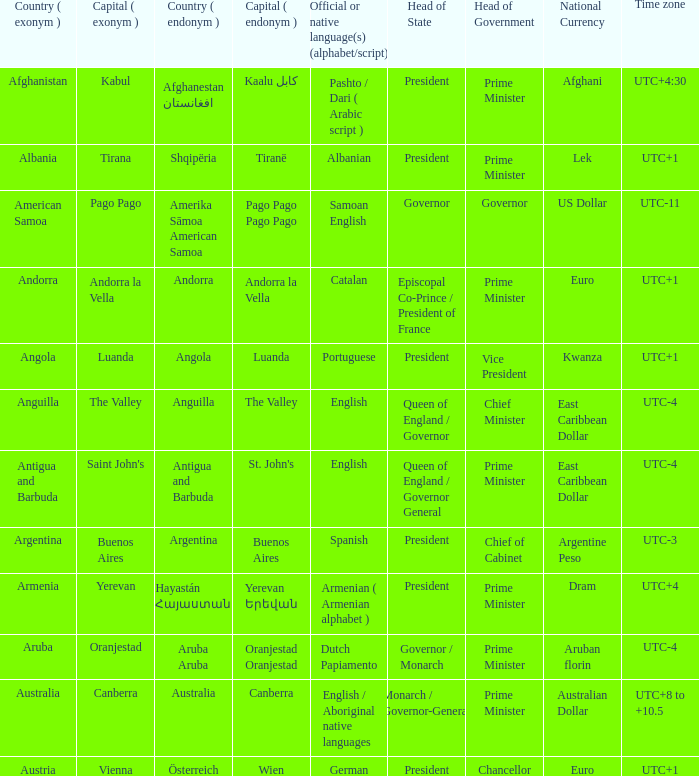What is the local name given to the city of Canberra? Canberra. Would you mind parsing the complete table? {'header': ['Country ( exonym )', 'Capital ( exonym )', 'Country ( endonym )', 'Capital ( endonym )', 'Official or native language(s) (alphabet/script)', 'Head of State', 'Head of Government', 'National Currency', 'Time zone'], 'rows': [['Afghanistan', 'Kabul', 'Afghanestan افغانستان', 'Kaalu كابل', 'Pashto / Dari ( Arabic script )', 'President', 'Prime Minister', 'Afghani', 'UTC+4:30'], ['Albania', 'Tirana', 'Shqipëria', 'Tiranë', 'Albanian', 'President', 'Prime Minister', 'Lek', 'UTC+1'], ['American Samoa', 'Pago Pago', 'Amerika Sāmoa American Samoa', 'Pago Pago Pago Pago', 'Samoan English', 'Governor', 'Governor', 'US Dollar', 'UTC-11'], ['Andorra', 'Andorra la Vella', 'Andorra', 'Andorra la Vella', 'Catalan', 'Episcopal Co-Prince / President of France', 'Prime Minister', 'Euro', 'UTC+1'], ['Angola', 'Luanda', 'Angola', 'Luanda', 'Portuguese', 'President', 'Vice President', 'Kwanza', 'UTC+1'], ['Anguilla', 'The Valley', 'Anguilla', 'The Valley', 'English', 'Queen of England / Governor', 'Chief Minister', 'East Caribbean Dollar', 'UTC-4'], ['Antigua and Barbuda', "Saint John's", 'Antigua and Barbuda', "St. John's", 'English', 'Queen of England / Governor General', 'Prime Minister', 'East Caribbean Dollar', 'UTC-4'], ['Argentina', 'Buenos Aires', 'Argentina', 'Buenos Aires', 'Spanish', 'President', 'Chief of Cabinet', 'Argentine Peso', 'UTC-3'], ['Armenia', 'Yerevan', 'Hayastán Հայաստան', 'Yerevan Երեվան', 'Armenian ( Armenian alphabet )', 'President', 'Prime Minister', 'Dram', 'UTC+4'], ['Aruba', 'Oranjestad', 'Aruba Aruba', 'Oranjestad Oranjestad', 'Dutch Papiamento', 'Governor / Monarch', 'Prime Minister', 'Aruban florin', 'UTC-4'], ['Australia', 'Canberra', 'Australia', 'Canberra', 'English / Aboriginal native languages', 'Monarch / Governor-General', 'Prime Minister', 'Australian Dollar', 'UTC+8 to +10.5'], ['Austria', 'Vienna', 'Österreich', 'Wien', 'German', 'President', 'Chancellor', 'Euro', 'UTC+1']]} 